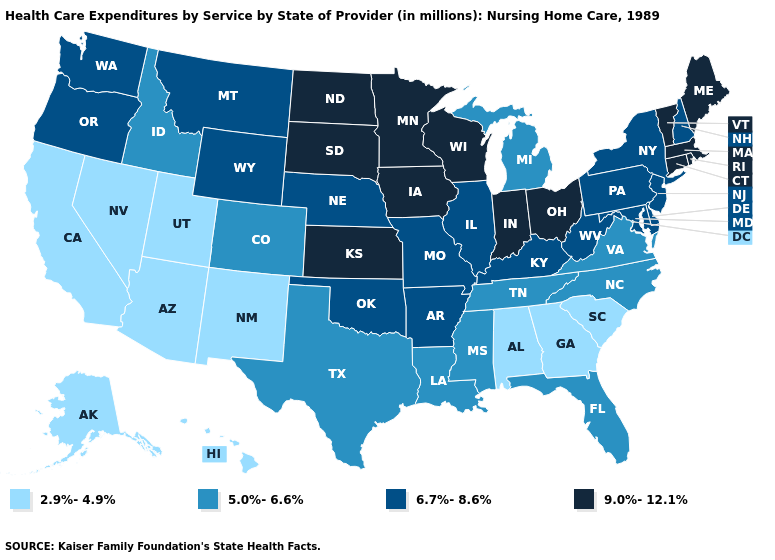Does Nevada have a lower value than Hawaii?
Quick response, please. No. What is the value of Maryland?
Answer briefly. 6.7%-8.6%. Which states have the lowest value in the USA?
Keep it brief. Alabama, Alaska, Arizona, California, Georgia, Hawaii, Nevada, New Mexico, South Carolina, Utah. How many symbols are there in the legend?
Write a very short answer. 4. Is the legend a continuous bar?
Write a very short answer. No. Name the states that have a value in the range 6.7%-8.6%?
Concise answer only. Arkansas, Delaware, Illinois, Kentucky, Maryland, Missouri, Montana, Nebraska, New Hampshire, New Jersey, New York, Oklahoma, Oregon, Pennsylvania, Washington, West Virginia, Wyoming. Does Vermont have a lower value than New Jersey?
Write a very short answer. No. Which states have the lowest value in the USA?
Short answer required. Alabama, Alaska, Arizona, California, Georgia, Hawaii, Nevada, New Mexico, South Carolina, Utah. What is the value of Maryland?
Write a very short answer. 6.7%-8.6%. Does the first symbol in the legend represent the smallest category?
Be succinct. Yes. What is the value of New Jersey?
Give a very brief answer. 6.7%-8.6%. Does the map have missing data?
Quick response, please. No. Does Arkansas have the highest value in the South?
Give a very brief answer. Yes. What is the value of Nevada?
Be succinct. 2.9%-4.9%. 